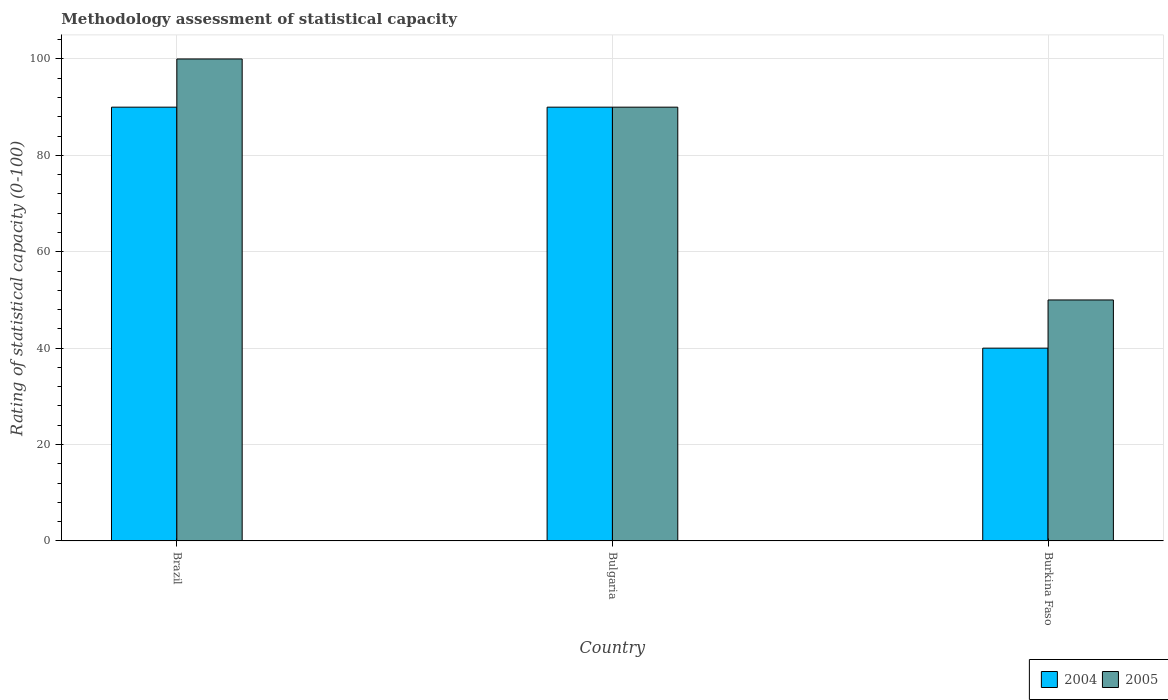How many different coloured bars are there?
Your answer should be very brief. 2. How many groups of bars are there?
Offer a terse response. 3. Are the number of bars per tick equal to the number of legend labels?
Offer a very short reply. Yes. Are the number of bars on each tick of the X-axis equal?
Offer a terse response. Yes. In how many cases, is the number of bars for a given country not equal to the number of legend labels?
Keep it short and to the point. 0. What is the rating of statistical capacity in 2004 in Burkina Faso?
Your answer should be compact. 40. Across all countries, what is the minimum rating of statistical capacity in 2004?
Provide a short and direct response. 40. In which country was the rating of statistical capacity in 2005 maximum?
Ensure brevity in your answer.  Brazil. In which country was the rating of statistical capacity in 2005 minimum?
Ensure brevity in your answer.  Burkina Faso. What is the total rating of statistical capacity in 2004 in the graph?
Provide a short and direct response. 220. What is the difference between the rating of statistical capacity in 2005 in Brazil and that in Burkina Faso?
Keep it short and to the point. 50. What is the difference between the rating of statistical capacity in 2005 in Bulgaria and the rating of statistical capacity in 2004 in Brazil?
Provide a succinct answer. 0. What is the average rating of statistical capacity in 2004 per country?
Your response must be concise. 73.33. What is the difference between the rating of statistical capacity of/in 2005 and rating of statistical capacity of/in 2004 in Bulgaria?
Your answer should be very brief. 0. What is the ratio of the rating of statistical capacity in 2004 in Brazil to that in Burkina Faso?
Your answer should be very brief. 2.25. Is the difference between the rating of statistical capacity in 2005 in Brazil and Burkina Faso greater than the difference between the rating of statistical capacity in 2004 in Brazil and Burkina Faso?
Provide a short and direct response. No. What is the difference between the highest and the second highest rating of statistical capacity in 2005?
Your response must be concise. -10. What is the difference between the highest and the lowest rating of statistical capacity in 2005?
Offer a terse response. 50. Is the sum of the rating of statistical capacity in 2004 in Brazil and Burkina Faso greater than the maximum rating of statistical capacity in 2005 across all countries?
Offer a very short reply. Yes. How many bars are there?
Your answer should be very brief. 6. What is the difference between two consecutive major ticks on the Y-axis?
Your answer should be very brief. 20. Does the graph contain grids?
Provide a succinct answer. Yes. Where does the legend appear in the graph?
Provide a succinct answer. Bottom right. How many legend labels are there?
Offer a terse response. 2. How are the legend labels stacked?
Provide a succinct answer. Horizontal. What is the title of the graph?
Offer a terse response. Methodology assessment of statistical capacity. What is the label or title of the Y-axis?
Offer a terse response. Rating of statistical capacity (0-100). What is the Rating of statistical capacity (0-100) in 2005 in Bulgaria?
Offer a terse response. 90. What is the Rating of statistical capacity (0-100) of 2004 in Burkina Faso?
Provide a succinct answer. 40. Across all countries, what is the maximum Rating of statistical capacity (0-100) in 2004?
Ensure brevity in your answer.  90. Across all countries, what is the minimum Rating of statistical capacity (0-100) in 2004?
Your answer should be compact. 40. Across all countries, what is the minimum Rating of statistical capacity (0-100) in 2005?
Your answer should be compact. 50. What is the total Rating of statistical capacity (0-100) of 2004 in the graph?
Your response must be concise. 220. What is the total Rating of statistical capacity (0-100) in 2005 in the graph?
Provide a short and direct response. 240. What is the difference between the Rating of statistical capacity (0-100) of 2004 in Brazil and that in Bulgaria?
Offer a very short reply. 0. What is the difference between the Rating of statistical capacity (0-100) in 2004 in Brazil and that in Burkina Faso?
Keep it short and to the point. 50. What is the difference between the Rating of statistical capacity (0-100) in 2005 in Brazil and that in Burkina Faso?
Keep it short and to the point. 50. What is the difference between the Rating of statistical capacity (0-100) of 2005 in Bulgaria and that in Burkina Faso?
Provide a succinct answer. 40. What is the difference between the Rating of statistical capacity (0-100) in 2004 in Brazil and the Rating of statistical capacity (0-100) in 2005 in Burkina Faso?
Your response must be concise. 40. What is the difference between the Rating of statistical capacity (0-100) in 2004 in Bulgaria and the Rating of statistical capacity (0-100) in 2005 in Burkina Faso?
Provide a short and direct response. 40. What is the average Rating of statistical capacity (0-100) in 2004 per country?
Your answer should be compact. 73.33. What is the average Rating of statistical capacity (0-100) in 2005 per country?
Provide a succinct answer. 80. What is the ratio of the Rating of statistical capacity (0-100) in 2004 in Brazil to that in Burkina Faso?
Your answer should be very brief. 2.25. What is the ratio of the Rating of statistical capacity (0-100) in 2004 in Bulgaria to that in Burkina Faso?
Your answer should be compact. 2.25. What is the difference between the highest and the second highest Rating of statistical capacity (0-100) in 2004?
Keep it short and to the point. 0. What is the difference between the highest and the lowest Rating of statistical capacity (0-100) of 2004?
Offer a very short reply. 50. What is the difference between the highest and the lowest Rating of statistical capacity (0-100) of 2005?
Offer a terse response. 50. 